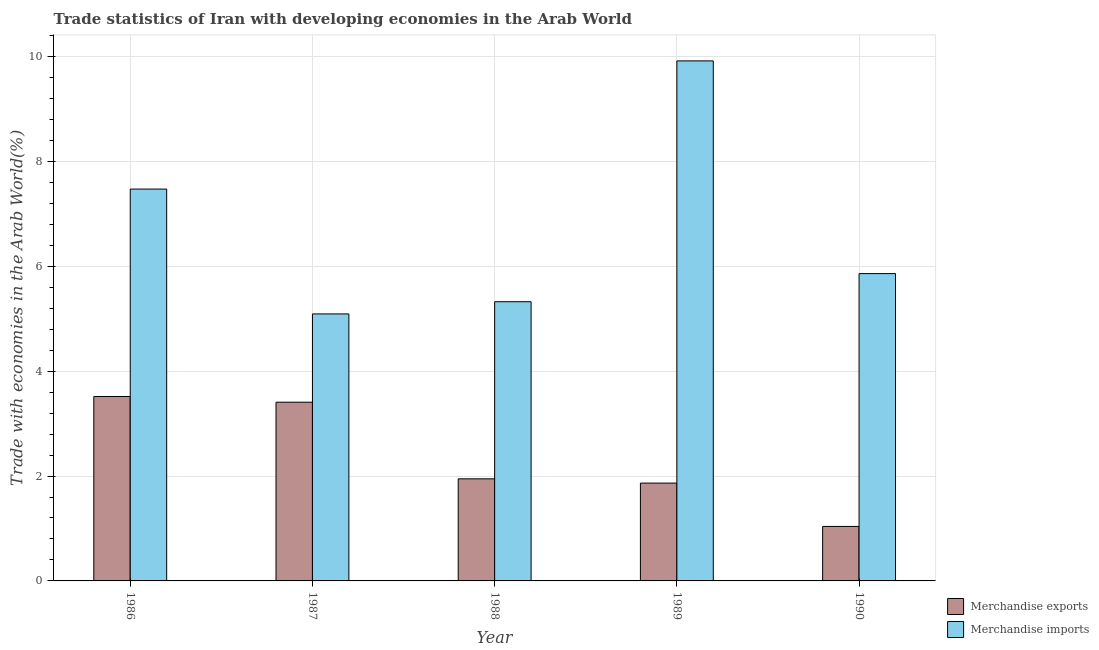How many different coloured bars are there?
Make the answer very short. 2. How many groups of bars are there?
Your response must be concise. 5. Are the number of bars per tick equal to the number of legend labels?
Keep it short and to the point. Yes. Are the number of bars on each tick of the X-axis equal?
Make the answer very short. Yes. How many bars are there on the 2nd tick from the left?
Your response must be concise. 2. What is the label of the 5th group of bars from the left?
Give a very brief answer. 1990. What is the merchandise exports in 1990?
Ensure brevity in your answer.  1.04. Across all years, what is the maximum merchandise exports?
Your answer should be compact. 3.52. Across all years, what is the minimum merchandise exports?
Your response must be concise. 1.04. In which year was the merchandise exports maximum?
Keep it short and to the point. 1986. What is the total merchandise imports in the graph?
Your answer should be compact. 33.66. What is the difference between the merchandise imports in 1986 and that in 1988?
Offer a terse response. 2.15. What is the difference between the merchandise exports in 1990 and the merchandise imports in 1988?
Offer a very short reply. -0.91. What is the average merchandise imports per year?
Provide a short and direct response. 6.73. What is the ratio of the merchandise exports in 1987 to that in 1988?
Ensure brevity in your answer.  1.75. Is the merchandise imports in 1986 less than that in 1990?
Ensure brevity in your answer.  No. Is the difference between the merchandise exports in 1986 and 1990 greater than the difference between the merchandise imports in 1986 and 1990?
Your response must be concise. No. What is the difference between the highest and the second highest merchandise exports?
Make the answer very short. 0.11. What is the difference between the highest and the lowest merchandise imports?
Keep it short and to the point. 4.83. Is the sum of the merchandise imports in 1986 and 1990 greater than the maximum merchandise exports across all years?
Ensure brevity in your answer.  Yes. What does the 2nd bar from the right in 1986 represents?
Your answer should be very brief. Merchandise exports. Are all the bars in the graph horizontal?
Make the answer very short. No. Where does the legend appear in the graph?
Offer a terse response. Bottom right. How many legend labels are there?
Your response must be concise. 2. What is the title of the graph?
Make the answer very short. Trade statistics of Iran with developing economies in the Arab World. Does "Passenger Transport Items" appear as one of the legend labels in the graph?
Offer a terse response. No. What is the label or title of the Y-axis?
Provide a succinct answer. Trade with economies in the Arab World(%). What is the Trade with economies in the Arab World(%) in Merchandise exports in 1986?
Offer a very short reply. 3.52. What is the Trade with economies in the Arab World(%) in Merchandise imports in 1986?
Give a very brief answer. 7.47. What is the Trade with economies in the Arab World(%) of Merchandise exports in 1987?
Your response must be concise. 3.41. What is the Trade with economies in the Arab World(%) of Merchandise imports in 1987?
Your answer should be very brief. 5.09. What is the Trade with economies in the Arab World(%) in Merchandise exports in 1988?
Provide a short and direct response. 1.95. What is the Trade with economies in the Arab World(%) in Merchandise imports in 1988?
Your answer should be compact. 5.32. What is the Trade with economies in the Arab World(%) in Merchandise exports in 1989?
Your response must be concise. 1.87. What is the Trade with economies in the Arab World(%) of Merchandise imports in 1989?
Your response must be concise. 9.92. What is the Trade with economies in the Arab World(%) in Merchandise exports in 1990?
Provide a succinct answer. 1.04. What is the Trade with economies in the Arab World(%) in Merchandise imports in 1990?
Offer a very short reply. 5.86. Across all years, what is the maximum Trade with economies in the Arab World(%) of Merchandise exports?
Ensure brevity in your answer.  3.52. Across all years, what is the maximum Trade with economies in the Arab World(%) of Merchandise imports?
Your response must be concise. 9.92. Across all years, what is the minimum Trade with economies in the Arab World(%) in Merchandise exports?
Give a very brief answer. 1.04. Across all years, what is the minimum Trade with economies in the Arab World(%) of Merchandise imports?
Ensure brevity in your answer.  5.09. What is the total Trade with economies in the Arab World(%) in Merchandise exports in the graph?
Your answer should be very brief. 11.78. What is the total Trade with economies in the Arab World(%) in Merchandise imports in the graph?
Your response must be concise. 33.66. What is the difference between the Trade with economies in the Arab World(%) in Merchandise exports in 1986 and that in 1987?
Provide a succinct answer. 0.11. What is the difference between the Trade with economies in the Arab World(%) in Merchandise imports in 1986 and that in 1987?
Provide a short and direct response. 2.38. What is the difference between the Trade with economies in the Arab World(%) in Merchandise exports in 1986 and that in 1988?
Your answer should be very brief. 1.57. What is the difference between the Trade with economies in the Arab World(%) of Merchandise imports in 1986 and that in 1988?
Provide a short and direct response. 2.15. What is the difference between the Trade with economies in the Arab World(%) in Merchandise exports in 1986 and that in 1989?
Offer a very short reply. 1.65. What is the difference between the Trade with economies in the Arab World(%) of Merchandise imports in 1986 and that in 1989?
Keep it short and to the point. -2.44. What is the difference between the Trade with economies in the Arab World(%) in Merchandise exports in 1986 and that in 1990?
Provide a short and direct response. 2.48. What is the difference between the Trade with economies in the Arab World(%) of Merchandise imports in 1986 and that in 1990?
Offer a very short reply. 1.61. What is the difference between the Trade with economies in the Arab World(%) in Merchandise exports in 1987 and that in 1988?
Your answer should be compact. 1.46. What is the difference between the Trade with economies in the Arab World(%) in Merchandise imports in 1987 and that in 1988?
Your answer should be very brief. -0.23. What is the difference between the Trade with economies in the Arab World(%) in Merchandise exports in 1987 and that in 1989?
Ensure brevity in your answer.  1.54. What is the difference between the Trade with economies in the Arab World(%) in Merchandise imports in 1987 and that in 1989?
Offer a terse response. -4.83. What is the difference between the Trade with economies in the Arab World(%) of Merchandise exports in 1987 and that in 1990?
Your answer should be compact. 2.37. What is the difference between the Trade with economies in the Arab World(%) in Merchandise imports in 1987 and that in 1990?
Your answer should be compact. -0.77. What is the difference between the Trade with economies in the Arab World(%) in Merchandise exports in 1988 and that in 1989?
Give a very brief answer. 0.08. What is the difference between the Trade with economies in the Arab World(%) in Merchandise imports in 1988 and that in 1989?
Offer a very short reply. -4.59. What is the difference between the Trade with economies in the Arab World(%) of Merchandise exports in 1988 and that in 1990?
Your answer should be very brief. 0.91. What is the difference between the Trade with economies in the Arab World(%) of Merchandise imports in 1988 and that in 1990?
Offer a terse response. -0.54. What is the difference between the Trade with economies in the Arab World(%) in Merchandise exports in 1989 and that in 1990?
Offer a very short reply. 0.83. What is the difference between the Trade with economies in the Arab World(%) of Merchandise imports in 1989 and that in 1990?
Your answer should be compact. 4.06. What is the difference between the Trade with economies in the Arab World(%) of Merchandise exports in 1986 and the Trade with economies in the Arab World(%) of Merchandise imports in 1987?
Ensure brevity in your answer.  -1.57. What is the difference between the Trade with economies in the Arab World(%) in Merchandise exports in 1986 and the Trade with economies in the Arab World(%) in Merchandise imports in 1988?
Provide a succinct answer. -1.81. What is the difference between the Trade with economies in the Arab World(%) of Merchandise exports in 1986 and the Trade with economies in the Arab World(%) of Merchandise imports in 1989?
Your answer should be compact. -6.4. What is the difference between the Trade with economies in the Arab World(%) in Merchandise exports in 1986 and the Trade with economies in the Arab World(%) in Merchandise imports in 1990?
Your response must be concise. -2.34. What is the difference between the Trade with economies in the Arab World(%) in Merchandise exports in 1987 and the Trade with economies in the Arab World(%) in Merchandise imports in 1988?
Ensure brevity in your answer.  -1.92. What is the difference between the Trade with economies in the Arab World(%) of Merchandise exports in 1987 and the Trade with economies in the Arab World(%) of Merchandise imports in 1989?
Provide a succinct answer. -6.51. What is the difference between the Trade with economies in the Arab World(%) in Merchandise exports in 1987 and the Trade with economies in the Arab World(%) in Merchandise imports in 1990?
Your response must be concise. -2.45. What is the difference between the Trade with economies in the Arab World(%) in Merchandise exports in 1988 and the Trade with economies in the Arab World(%) in Merchandise imports in 1989?
Offer a very short reply. -7.97. What is the difference between the Trade with economies in the Arab World(%) in Merchandise exports in 1988 and the Trade with economies in the Arab World(%) in Merchandise imports in 1990?
Give a very brief answer. -3.91. What is the difference between the Trade with economies in the Arab World(%) of Merchandise exports in 1989 and the Trade with economies in the Arab World(%) of Merchandise imports in 1990?
Ensure brevity in your answer.  -3.99. What is the average Trade with economies in the Arab World(%) of Merchandise exports per year?
Keep it short and to the point. 2.36. What is the average Trade with economies in the Arab World(%) in Merchandise imports per year?
Your answer should be very brief. 6.73. In the year 1986, what is the difference between the Trade with economies in the Arab World(%) of Merchandise exports and Trade with economies in the Arab World(%) of Merchandise imports?
Your answer should be compact. -3.96. In the year 1987, what is the difference between the Trade with economies in the Arab World(%) in Merchandise exports and Trade with economies in the Arab World(%) in Merchandise imports?
Your answer should be compact. -1.68. In the year 1988, what is the difference between the Trade with economies in the Arab World(%) of Merchandise exports and Trade with economies in the Arab World(%) of Merchandise imports?
Your answer should be very brief. -3.38. In the year 1989, what is the difference between the Trade with economies in the Arab World(%) of Merchandise exports and Trade with economies in the Arab World(%) of Merchandise imports?
Give a very brief answer. -8.05. In the year 1990, what is the difference between the Trade with economies in the Arab World(%) of Merchandise exports and Trade with economies in the Arab World(%) of Merchandise imports?
Keep it short and to the point. -4.82. What is the ratio of the Trade with economies in the Arab World(%) in Merchandise exports in 1986 to that in 1987?
Make the answer very short. 1.03. What is the ratio of the Trade with economies in the Arab World(%) of Merchandise imports in 1986 to that in 1987?
Provide a short and direct response. 1.47. What is the ratio of the Trade with economies in the Arab World(%) in Merchandise exports in 1986 to that in 1988?
Keep it short and to the point. 1.81. What is the ratio of the Trade with economies in the Arab World(%) in Merchandise imports in 1986 to that in 1988?
Offer a very short reply. 1.4. What is the ratio of the Trade with economies in the Arab World(%) of Merchandise exports in 1986 to that in 1989?
Ensure brevity in your answer.  1.89. What is the ratio of the Trade with economies in the Arab World(%) in Merchandise imports in 1986 to that in 1989?
Your answer should be very brief. 0.75. What is the ratio of the Trade with economies in the Arab World(%) of Merchandise exports in 1986 to that in 1990?
Provide a short and direct response. 3.38. What is the ratio of the Trade with economies in the Arab World(%) of Merchandise imports in 1986 to that in 1990?
Offer a very short reply. 1.28. What is the ratio of the Trade with economies in the Arab World(%) of Merchandise exports in 1987 to that in 1988?
Provide a short and direct response. 1.75. What is the ratio of the Trade with economies in the Arab World(%) in Merchandise imports in 1987 to that in 1988?
Your answer should be compact. 0.96. What is the ratio of the Trade with economies in the Arab World(%) in Merchandise exports in 1987 to that in 1989?
Provide a succinct answer. 1.83. What is the ratio of the Trade with economies in the Arab World(%) in Merchandise imports in 1987 to that in 1989?
Make the answer very short. 0.51. What is the ratio of the Trade with economies in the Arab World(%) of Merchandise exports in 1987 to that in 1990?
Keep it short and to the point. 3.28. What is the ratio of the Trade with economies in the Arab World(%) in Merchandise imports in 1987 to that in 1990?
Your response must be concise. 0.87. What is the ratio of the Trade with economies in the Arab World(%) in Merchandise exports in 1988 to that in 1989?
Your answer should be compact. 1.04. What is the ratio of the Trade with economies in the Arab World(%) in Merchandise imports in 1988 to that in 1989?
Give a very brief answer. 0.54. What is the ratio of the Trade with economies in the Arab World(%) in Merchandise exports in 1988 to that in 1990?
Your answer should be very brief. 1.87. What is the ratio of the Trade with economies in the Arab World(%) in Merchandise imports in 1988 to that in 1990?
Keep it short and to the point. 0.91. What is the ratio of the Trade with economies in the Arab World(%) of Merchandise exports in 1989 to that in 1990?
Offer a very short reply. 1.8. What is the ratio of the Trade with economies in the Arab World(%) in Merchandise imports in 1989 to that in 1990?
Give a very brief answer. 1.69. What is the difference between the highest and the second highest Trade with economies in the Arab World(%) of Merchandise exports?
Offer a terse response. 0.11. What is the difference between the highest and the second highest Trade with economies in the Arab World(%) in Merchandise imports?
Provide a short and direct response. 2.44. What is the difference between the highest and the lowest Trade with economies in the Arab World(%) in Merchandise exports?
Give a very brief answer. 2.48. What is the difference between the highest and the lowest Trade with economies in the Arab World(%) in Merchandise imports?
Offer a terse response. 4.83. 